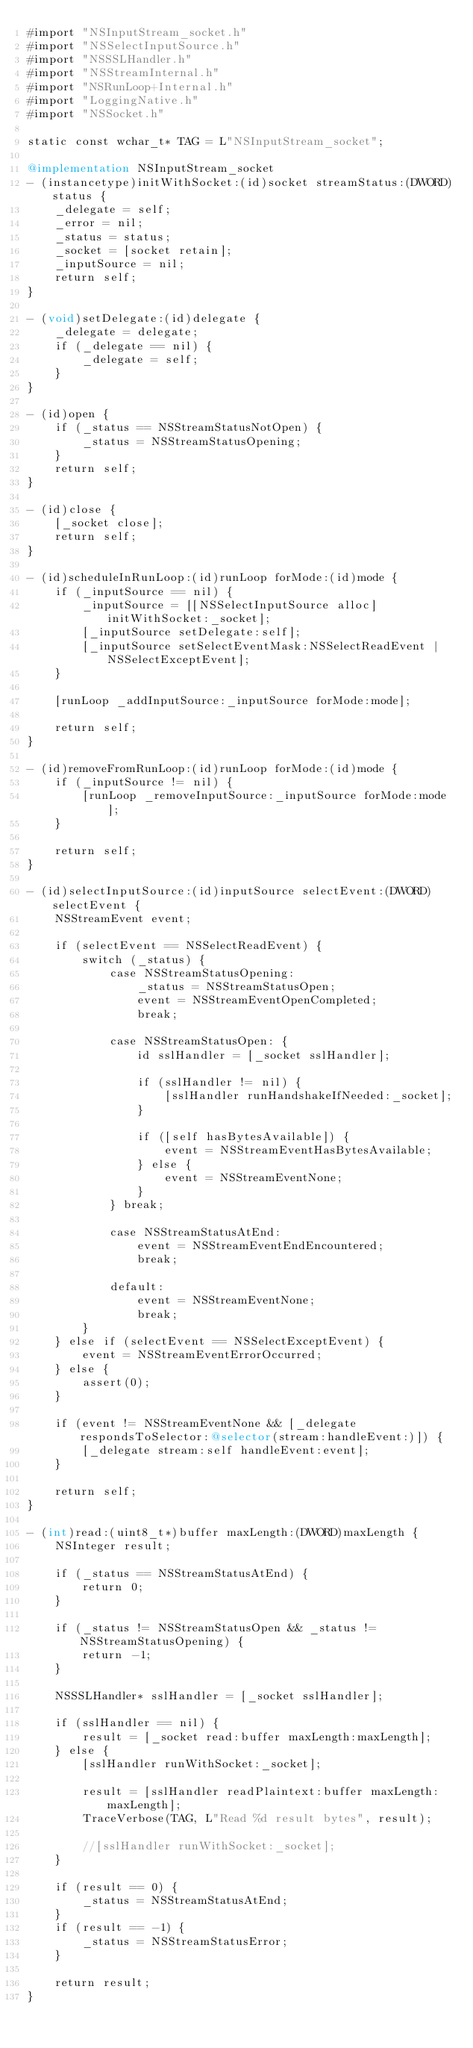Convert code to text. <code><loc_0><loc_0><loc_500><loc_500><_ObjectiveC_>#import "NSInputStream_socket.h"
#import "NSSelectInputSource.h"
#import "NSSSLHandler.h"
#import "NSStreamInternal.h"
#import "NSRunLoop+Internal.h"
#import "LoggingNative.h"
#import "NSSocket.h"

static const wchar_t* TAG = L"NSInputStream_socket";

@implementation NSInputStream_socket
- (instancetype)initWithSocket:(id)socket streamStatus:(DWORD)status {
    _delegate = self;
    _error = nil;
    _status = status;
    _socket = [socket retain];
    _inputSource = nil;
    return self;
}

- (void)setDelegate:(id)delegate {
    _delegate = delegate;
    if (_delegate == nil) {
        _delegate = self;
    }
}

- (id)open {
    if (_status == NSStreamStatusNotOpen) {
        _status = NSStreamStatusOpening;
    }
    return self;
}

- (id)close {
    [_socket close];
    return self;
}

- (id)scheduleInRunLoop:(id)runLoop forMode:(id)mode {
    if (_inputSource == nil) {
        _inputSource = [[NSSelectInputSource alloc] initWithSocket:_socket];
        [_inputSource setDelegate:self];
        [_inputSource setSelectEventMask:NSSelectReadEvent | NSSelectExceptEvent];
    }

    [runLoop _addInputSource:_inputSource forMode:mode];

    return self;
}

- (id)removeFromRunLoop:(id)runLoop forMode:(id)mode {
    if (_inputSource != nil) {
        [runLoop _removeInputSource:_inputSource forMode:mode];
    }

    return self;
}

- (id)selectInputSource:(id)inputSource selectEvent:(DWORD)selectEvent {
    NSStreamEvent event;

    if (selectEvent == NSSelectReadEvent) {
        switch (_status) {
            case NSStreamStatusOpening:
                _status = NSStreamStatusOpen;
                event = NSStreamEventOpenCompleted;
                break;

            case NSStreamStatusOpen: {
                id sslHandler = [_socket sslHandler];

                if (sslHandler != nil) {
                    [sslHandler runHandshakeIfNeeded:_socket];
                }

                if ([self hasBytesAvailable]) {
                    event = NSStreamEventHasBytesAvailable;
                } else {
                    event = NSStreamEventNone;
                }
            } break;

            case NSStreamStatusAtEnd:
                event = NSStreamEventEndEncountered;
                break;

            default:
                event = NSStreamEventNone;
                break;
        }
    } else if (selectEvent == NSSelectExceptEvent) {
        event = NSStreamEventErrorOccurred;
    } else {
        assert(0);
    }

    if (event != NSStreamEventNone && [_delegate respondsToSelector:@selector(stream:handleEvent:)]) {
        [_delegate stream:self handleEvent:event];
    }

    return self;
}

- (int)read:(uint8_t*)buffer maxLength:(DWORD)maxLength {
    NSInteger result;

    if (_status == NSStreamStatusAtEnd) {
        return 0;
    }

    if (_status != NSStreamStatusOpen && _status != NSStreamStatusOpening) {
        return -1;
    }

    NSSSLHandler* sslHandler = [_socket sslHandler];

    if (sslHandler == nil) {
        result = [_socket read:buffer maxLength:maxLength];
    } else {
        [sslHandler runWithSocket:_socket];

        result = [sslHandler readPlaintext:buffer maxLength:maxLength];
        TraceVerbose(TAG, L"Read %d result bytes", result);

        //[sslHandler runWithSocket:_socket];
    }

    if (result == 0) {
        _status = NSStreamStatusAtEnd;
    }
    if (result == -1) {
        _status = NSStreamStatusError;
    }

    return result;
}
</code> 